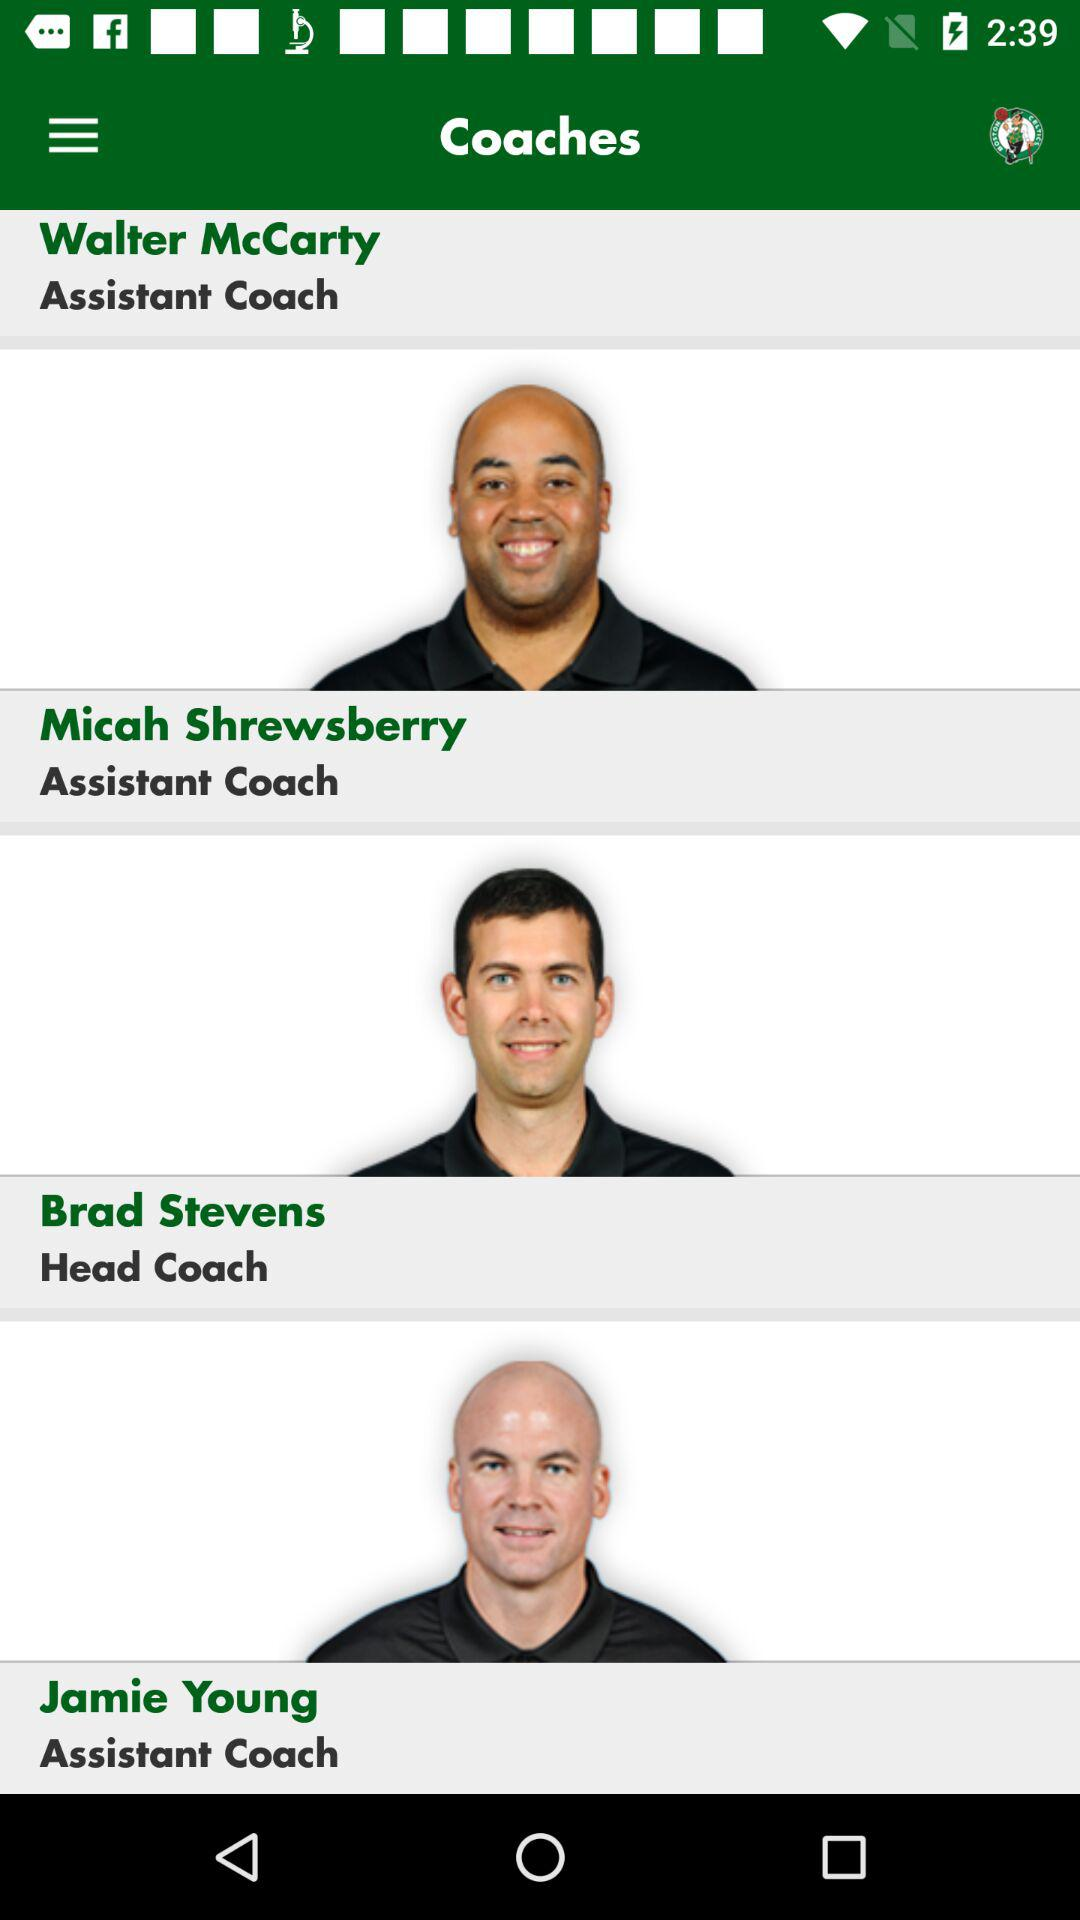What are the options in the drop-down menu?
When the provided information is insufficient, respond with <no answer>. <no answer> 